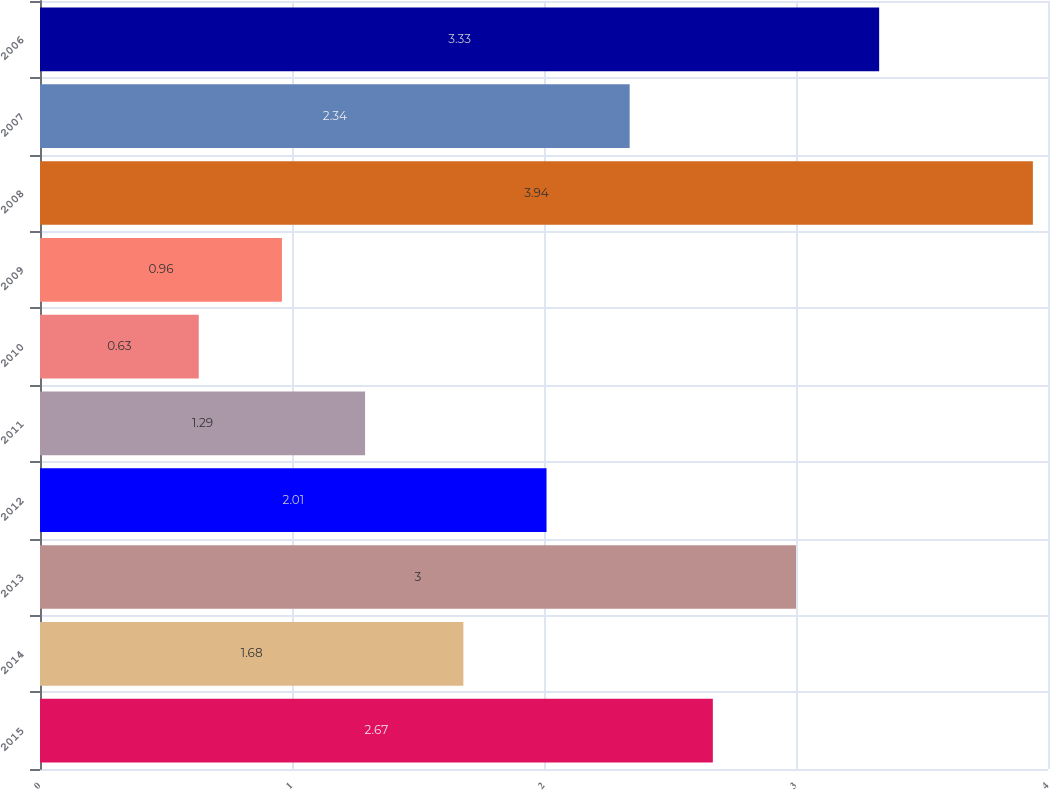Convert chart. <chart><loc_0><loc_0><loc_500><loc_500><bar_chart><fcel>2015<fcel>2014<fcel>2013<fcel>2012<fcel>2011<fcel>2010<fcel>2009<fcel>2008<fcel>2007<fcel>2006<nl><fcel>2.67<fcel>1.68<fcel>3<fcel>2.01<fcel>1.29<fcel>0.63<fcel>0.96<fcel>3.94<fcel>2.34<fcel>3.33<nl></chart> 